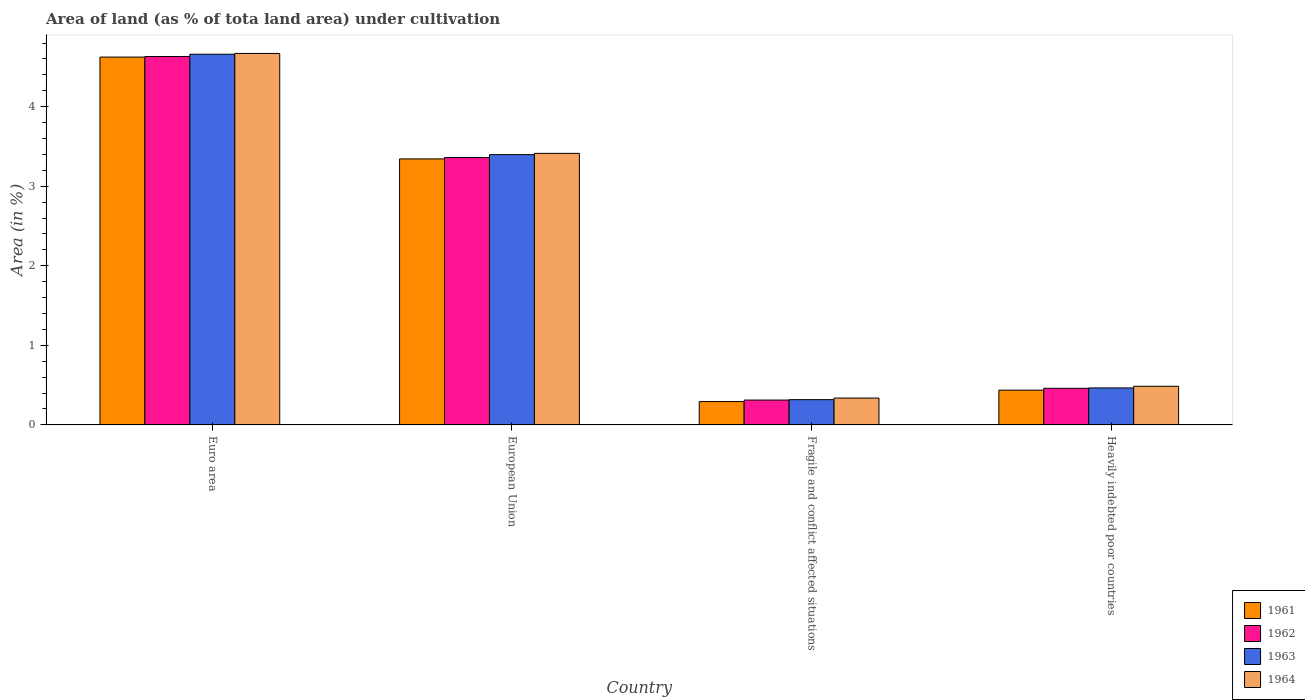How many different coloured bars are there?
Give a very brief answer. 4. How many groups of bars are there?
Provide a succinct answer. 4. Are the number of bars per tick equal to the number of legend labels?
Make the answer very short. Yes. Are the number of bars on each tick of the X-axis equal?
Provide a succinct answer. Yes. What is the label of the 4th group of bars from the left?
Your answer should be compact. Heavily indebted poor countries. In how many cases, is the number of bars for a given country not equal to the number of legend labels?
Your answer should be very brief. 0. What is the percentage of land under cultivation in 1961 in Euro area?
Your answer should be compact. 4.62. Across all countries, what is the maximum percentage of land under cultivation in 1964?
Provide a short and direct response. 4.67. Across all countries, what is the minimum percentage of land under cultivation in 1964?
Ensure brevity in your answer.  0.34. In which country was the percentage of land under cultivation in 1961 maximum?
Make the answer very short. Euro area. In which country was the percentage of land under cultivation in 1961 minimum?
Offer a terse response. Fragile and conflict affected situations. What is the total percentage of land under cultivation in 1961 in the graph?
Offer a terse response. 8.7. What is the difference between the percentage of land under cultivation in 1961 in Fragile and conflict affected situations and that in Heavily indebted poor countries?
Offer a terse response. -0.14. What is the difference between the percentage of land under cultivation in 1962 in Heavily indebted poor countries and the percentage of land under cultivation in 1963 in European Union?
Your answer should be compact. -2.94. What is the average percentage of land under cultivation in 1963 per country?
Your answer should be compact. 2.21. What is the difference between the percentage of land under cultivation of/in 1963 and percentage of land under cultivation of/in 1962 in Fragile and conflict affected situations?
Offer a terse response. 0.01. What is the ratio of the percentage of land under cultivation in 1961 in European Union to that in Fragile and conflict affected situations?
Offer a very short reply. 11.39. Is the percentage of land under cultivation in 1962 in Euro area less than that in Fragile and conflict affected situations?
Offer a terse response. No. Is the difference between the percentage of land under cultivation in 1963 in Euro area and European Union greater than the difference between the percentage of land under cultivation in 1962 in Euro area and European Union?
Give a very brief answer. No. What is the difference between the highest and the second highest percentage of land under cultivation in 1962?
Your answer should be very brief. -2.9. What is the difference between the highest and the lowest percentage of land under cultivation in 1964?
Your response must be concise. 4.33. Is the sum of the percentage of land under cultivation in 1963 in Euro area and Heavily indebted poor countries greater than the maximum percentage of land under cultivation in 1964 across all countries?
Offer a terse response. Yes. What does the 3rd bar from the left in Heavily indebted poor countries represents?
Keep it short and to the point. 1963. What does the 1st bar from the right in European Union represents?
Give a very brief answer. 1964. How many bars are there?
Ensure brevity in your answer.  16. How many countries are there in the graph?
Keep it short and to the point. 4. Are the values on the major ticks of Y-axis written in scientific E-notation?
Make the answer very short. No. Where does the legend appear in the graph?
Your answer should be compact. Bottom right. How many legend labels are there?
Offer a very short reply. 4. What is the title of the graph?
Your response must be concise. Area of land (as % of tota land area) under cultivation. What is the label or title of the Y-axis?
Give a very brief answer. Area (in %). What is the Area (in %) of 1961 in Euro area?
Your answer should be compact. 4.62. What is the Area (in %) in 1962 in Euro area?
Keep it short and to the point. 4.63. What is the Area (in %) in 1963 in Euro area?
Your response must be concise. 4.66. What is the Area (in %) in 1964 in Euro area?
Your answer should be very brief. 4.67. What is the Area (in %) in 1961 in European Union?
Offer a terse response. 3.34. What is the Area (in %) in 1962 in European Union?
Offer a very short reply. 3.36. What is the Area (in %) of 1963 in European Union?
Your answer should be compact. 3.4. What is the Area (in %) of 1964 in European Union?
Offer a very short reply. 3.41. What is the Area (in %) of 1961 in Fragile and conflict affected situations?
Your response must be concise. 0.29. What is the Area (in %) of 1962 in Fragile and conflict affected situations?
Your answer should be very brief. 0.31. What is the Area (in %) of 1963 in Fragile and conflict affected situations?
Your answer should be compact. 0.32. What is the Area (in %) in 1964 in Fragile and conflict affected situations?
Ensure brevity in your answer.  0.34. What is the Area (in %) in 1961 in Heavily indebted poor countries?
Offer a terse response. 0.44. What is the Area (in %) in 1962 in Heavily indebted poor countries?
Offer a terse response. 0.46. What is the Area (in %) in 1963 in Heavily indebted poor countries?
Your answer should be compact. 0.46. What is the Area (in %) in 1964 in Heavily indebted poor countries?
Keep it short and to the point. 0.49. Across all countries, what is the maximum Area (in %) of 1961?
Give a very brief answer. 4.62. Across all countries, what is the maximum Area (in %) of 1962?
Provide a short and direct response. 4.63. Across all countries, what is the maximum Area (in %) in 1963?
Your response must be concise. 4.66. Across all countries, what is the maximum Area (in %) of 1964?
Your answer should be compact. 4.67. Across all countries, what is the minimum Area (in %) of 1961?
Ensure brevity in your answer.  0.29. Across all countries, what is the minimum Area (in %) of 1962?
Your answer should be very brief. 0.31. Across all countries, what is the minimum Area (in %) in 1963?
Offer a very short reply. 0.32. Across all countries, what is the minimum Area (in %) in 1964?
Ensure brevity in your answer.  0.34. What is the total Area (in %) of 1961 in the graph?
Your answer should be compact. 8.7. What is the total Area (in %) of 1962 in the graph?
Offer a terse response. 8.76. What is the total Area (in %) of 1963 in the graph?
Make the answer very short. 8.84. What is the total Area (in %) in 1964 in the graph?
Your answer should be very brief. 8.91. What is the difference between the Area (in %) in 1961 in Euro area and that in European Union?
Your answer should be very brief. 1.28. What is the difference between the Area (in %) in 1962 in Euro area and that in European Union?
Make the answer very short. 1.27. What is the difference between the Area (in %) of 1963 in Euro area and that in European Union?
Provide a short and direct response. 1.26. What is the difference between the Area (in %) in 1964 in Euro area and that in European Union?
Your response must be concise. 1.26. What is the difference between the Area (in %) of 1961 in Euro area and that in Fragile and conflict affected situations?
Provide a succinct answer. 4.33. What is the difference between the Area (in %) of 1962 in Euro area and that in Fragile and conflict affected situations?
Your answer should be very brief. 4.32. What is the difference between the Area (in %) in 1963 in Euro area and that in Fragile and conflict affected situations?
Your answer should be very brief. 4.34. What is the difference between the Area (in %) in 1964 in Euro area and that in Fragile and conflict affected situations?
Offer a very short reply. 4.33. What is the difference between the Area (in %) of 1961 in Euro area and that in Heavily indebted poor countries?
Make the answer very short. 4.19. What is the difference between the Area (in %) of 1962 in Euro area and that in Heavily indebted poor countries?
Offer a terse response. 4.17. What is the difference between the Area (in %) in 1963 in Euro area and that in Heavily indebted poor countries?
Keep it short and to the point. 4.19. What is the difference between the Area (in %) in 1964 in Euro area and that in Heavily indebted poor countries?
Your response must be concise. 4.18. What is the difference between the Area (in %) of 1961 in European Union and that in Fragile and conflict affected situations?
Provide a succinct answer. 3.05. What is the difference between the Area (in %) in 1962 in European Union and that in Fragile and conflict affected situations?
Your answer should be very brief. 3.05. What is the difference between the Area (in %) of 1963 in European Union and that in Fragile and conflict affected situations?
Keep it short and to the point. 3.08. What is the difference between the Area (in %) in 1964 in European Union and that in Fragile and conflict affected situations?
Your answer should be compact. 3.08. What is the difference between the Area (in %) in 1961 in European Union and that in Heavily indebted poor countries?
Your answer should be compact. 2.91. What is the difference between the Area (in %) in 1962 in European Union and that in Heavily indebted poor countries?
Provide a succinct answer. 2.9. What is the difference between the Area (in %) of 1963 in European Union and that in Heavily indebted poor countries?
Make the answer very short. 2.93. What is the difference between the Area (in %) in 1964 in European Union and that in Heavily indebted poor countries?
Keep it short and to the point. 2.93. What is the difference between the Area (in %) in 1961 in Fragile and conflict affected situations and that in Heavily indebted poor countries?
Offer a very short reply. -0.14. What is the difference between the Area (in %) of 1962 in Fragile and conflict affected situations and that in Heavily indebted poor countries?
Ensure brevity in your answer.  -0.15. What is the difference between the Area (in %) in 1963 in Fragile and conflict affected situations and that in Heavily indebted poor countries?
Provide a short and direct response. -0.15. What is the difference between the Area (in %) of 1964 in Fragile and conflict affected situations and that in Heavily indebted poor countries?
Ensure brevity in your answer.  -0.15. What is the difference between the Area (in %) in 1961 in Euro area and the Area (in %) in 1962 in European Union?
Ensure brevity in your answer.  1.26. What is the difference between the Area (in %) of 1961 in Euro area and the Area (in %) of 1963 in European Union?
Give a very brief answer. 1.23. What is the difference between the Area (in %) in 1961 in Euro area and the Area (in %) in 1964 in European Union?
Provide a succinct answer. 1.21. What is the difference between the Area (in %) in 1962 in Euro area and the Area (in %) in 1963 in European Union?
Give a very brief answer. 1.23. What is the difference between the Area (in %) in 1962 in Euro area and the Area (in %) in 1964 in European Union?
Your response must be concise. 1.22. What is the difference between the Area (in %) of 1963 in Euro area and the Area (in %) of 1964 in European Union?
Provide a short and direct response. 1.25. What is the difference between the Area (in %) in 1961 in Euro area and the Area (in %) in 1962 in Fragile and conflict affected situations?
Offer a terse response. 4.31. What is the difference between the Area (in %) of 1961 in Euro area and the Area (in %) of 1963 in Fragile and conflict affected situations?
Offer a terse response. 4.31. What is the difference between the Area (in %) in 1961 in Euro area and the Area (in %) in 1964 in Fragile and conflict affected situations?
Ensure brevity in your answer.  4.29. What is the difference between the Area (in %) in 1962 in Euro area and the Area (in %) in 1963 in Fragile and conflict affected situations?
Keep it short and to the point. 4.31. What is the difference between the Area (in %) of 1962 in Euro area and the Area (in %) of 1964 in Fragile and conflict affected situations?
Your answer should be compact. 4.29. What is the difference between the Area (in %) in 1963 in Euro area and the Area (in %) in 1964 in Fragile and conflict affected situations?
Keep it short and to the point. 4.32. What is the difference between the Area (in %) of 1961 in Euro area and the Area (in %) of 1962 in Heavily indebted poor countries?
Offer a very short reply. 4.16. What is the difference between the Area (in %) in 1961 in Euro area and the Area (in %) in 1963 in Heavily indebted poor countries?
Offer a very short reply. 4.16. What is the difference between the Area (in %) of 1961 in Euro area and the Area (in %) of 1964 in Heavily indebted poor countries?
Provide a short and direct response. 4.14. What is the difference between the Area (in %) of 1962 in Euro area and the Area (in %) of 1963 in Heavily indebted poor countries?
Your answer should be compact. 4.17. What is the difference between the Area (in %) in 1962 in Euro area and the Area (in %) in 1964 in Heavily indebted poor countries?
Your answer should be compact. 4.15. What is the difference between the Area (in %) in 1963 in Euro area and the Area (in %) in 1964 in Heavily indebted poor countries?
Offer a very short reply. 4.17. What is the difference between the Area (in %) of 1961 in European Union and the Area (in %) of 1962 in Fragile and conflict affected situations?
Your response must be concise. 3.03. What is the difference between the Area (in %) in 1961 in European Union and the Area (in %) in 1963 in Fragile and conflict affected situations?
Provide a succinct answer. 3.03. What is the difference between the Area (in %) of 1961 in European Union and the Area (in %) of 1964 in Fragile and conflict affected situations?
Offer a terse response. 3.01. What is the difference between the Area (in %) in 1962 in European Union and the Area (in %) in 1963 in Fragile and conflict affected situations?
Make the answer very short. 3.04. What is the difference between the Area (in %) of 1962 in European Union and the Area (in %) of 1964 in Fragile and conflict affected situations?
Provide a short and direct response. 3.02. What is the difference between the Area (in %) in 1963 in European Union and the Area (in %) in 1964 in Fragile and conflict affected situations?
Provide a short and direct response. 3.06. What is the difference between the Area (in %) in 1961 in European Union and the Area (in %) in 1962 in Heavily indebted poor countries?
Your answer should be very brief. 2.88. What is the difference between the Area (in %) of 1961 in European Union and the Area (in %) of 1963 in Heavily indebted poor countries?
Give a very brief answer. 2.88. What is the difference between the Area (in %) in 1961 in European Union and the Area (in %) in 1964 in Heavily indebted poor countries?
Offer a terse response. 2.86. What is the difference between the Area (in %) of 1962 in European Union and the Area (in %) of 1963 in Heavily indebted poor countries?
Your answer should be very brief. 2.9. What is the difference between the Area (in %) in 1962 in European Union and the Area (in %) in 1964 in Heavily indebted poor countries?
Your response must be concise. 2.88. What is the difference between the Area (in %) of 1963 in European Union and the Area (in %) of 1964 in Heavily indebted poor countries?
Your response must be concise. 2.91. What is the difference between the Area (in %) of 1961 in Fragile and conflict affected situations and the Area (in %) of 1962 in Heavily indebted poor countries?
Provide a short and direct response. -0.17. What is the difference between the Area (in %) of 1961 in Fragile and conflict affected situations and the Area (in %) of 1963 in Heavily indebted poor countries?
Make the answer very short. -0.17. What is the difference between the Area (in %) of 1961 in Fragile and conflict affected situations and the Area (in %) of 1964 in Heavily indebted poor countries?
Keep it short and to the point. -0.19. What is the difference between the Area (in %) in 1962 in Fragile and conflict affected situations and the Area (in %) in 1963 in Heavily indebted poor countries?
Your answer should be compact. -0.15. What is the difference between the Area (in %) of 1962 in Fragile and conflict affected situations and the Area (in %) of 1964 in Heavily indebted poor countries?
Ensure brevity in your answer.  -0.17. What is the difference between the Area (in %) of 1963 in Fragile and conflict affected situations and the Area (in %) of 1964 in Heavily indebted poor countries?
Offer a very short reply. -0.17. What is the average Area (in %) of 1961 per country?
Offer a very short reply. 2.17. What is the average Area (in %) of 1962 per country?
Your answer should be compact. 2.19. What is the average Area (in %) of 1963 per country?
Your answer should be very brief. 2.21. What is the average Area (in %) in 1964 per country?
Make the answer very short. 2.23. What is the difference between the Area (in %) of 1961 and Area (in %) of 1962 in Euro area?
Your answer should be very brief. -0.01. What is the difference between the Area (in %) of 1961 and Area (in %) of 1963 in Euro area?
Keep it short and to the point. -0.04. What is the difference between the Area (in %) in 1961 and Area (in %) in 1964 in Euro area?
Give a very brief answer. -0.05. What is the difference between the Area (in %) of 1962 and Area (in %) of 1963 in Euro area?
Your answer should be compact. -0.03. What is the difference between the Area (in %) in 1962 and Area (in %) in 1964 in Euro area?
Your response must be concise. -0.04. What is the difference between the Area (in %) in 1963 and Area (in %) in 1964 in Euro area?
Make the answer very short. -0.01. What is the difference between the Area (in %) in 1961 and Area (in %) in 1962 in European Union?
Offer a terse response. -0.02. What is the difference between the Area (in %) of 1961 and Area (in %) of 1963 in European Union?
Your answer should be compact. -0.05. What is the difference between the Area (in %) of 1961 and Area (in %) of 1964 in European Union?
Offer a terse response. -0.07. What is the difference between the Area (in %) of 1962 and Area (in %) of 1963 in European Union?
Your answer should be compact. -0.04. What is the difference between the Area (in %) of 1962 and Area (in %) of 1964 in European Union?
Provide a succinct answer. -0.05. What is the difference between the Area (in %) of 1963 and Area (in %) of 1964 in European Union?
Offer a terse response. -0.02. What is the difference between the Area (in %) in 1961 and Area (in %) in 1962 in Fragile and conflict affected situations?
Offer a very short reply. -0.02. What is the difference between the Area (in %) of 1961 and Area (in %) of 1963 in Fragile and conflict affected situations?
Provide a short and direct response. -0.02. What is the difference between the Area (in %) in 1961 and Area (in %) in 1964 in Fragile and conflict affected situations?
Give a very brief answer. -0.04. What is the difference between the Area (in %) in 1962 and Area (in %) in 1963 in Fragile and conflict affected situations?
Offer a terse response. -0.01. What is the difference between the Area (in %) of 1962 and Area (in %) of 1964 in Fragile and conflict affected situations?
Offer a very short reply. -0.03. What is the difference between the Area (in %) in 1963 and Area (in %) in 1964 in Fragile and conflict affected situations?
Give a very brief answer. -0.02. What is the difference between the Area (in %) of 1961 and Area (in %) of 1962 in Heavily indebted poor countries?
Keep it short and to the point. -0.02. What is the difference between the Area (in %) of 1961 and Area (in %) of 1963 in Heavily indebted poor countries?
Your answer should be compact. -0.03. What is the difference between the Area (in %) in 1961 and Area (in %) in 1964 in Heavily indebted poor countries?
Your answer should be very brief. -0.05. What is the difference between the Area (in %) of 1962 and Area (in %) of 1963 in Heavily indebted poor countries?
Your response must be concise. -0. What is the difference between the Area (in %) in 1962 and Area (in %) in 1964 in Heavily indebted poor countries?
Your answer should be compact. -0.03. What is the difference between the Area (in %) in 1963 and Area (in %) in 1964 in Heavily indebted poor countries?
Keep it short and to the point. -0.02. What is the ratio of the Area (in %) in 1961 in Euro area to that in European Union?
Provide a short and direct response. 1.38. What is the ratio of the Area (in %) in 1962 in Euro area to that in European Union?
Your answer should be very brief. 1.38. What is the ratio of the Area (in %) in 1963 in Euro area to that in European Union?
Your response must be concise. 1.37. What is the ratio of the Area (in %) in 1964 in Euro area to that in European Union?
Offer a terse response. 1.37. What is the ratio of the Area (in %) of 1961 in Euro area to that in Fragile and conflict affected situations?
Your answer should be very brief. 15.76. What is the ratio of the Area (in %) in 1962 in Euro area to that in Fragile and conflict affected situations?
Keep it short and to the point. 14.83. What is the ratio of the Area (in %) in 1963 in Euro area to that in Fragile and conflict affected situations?
Offer a terse response. 14.67. What is the ratio of the Area (in %) of 1964 in Euro area to that in Fragile and conflict affected situations?
Offer a terse response. 13.83. What is the ratio of the Area (in %) in 1961 in Euro area to that in Heavily indebted poor countries?
Keep it short and to the point. 10.58. What is the ratio of the Area (in %) of 1962 in Euro area to that in Heavily indebted poor countries?
Offer a very short reply. 10.06. What is the ratio of the Area (in %) in 1963 in Euro area to that in Heavily indebted poor countries?
Provide a succinct answer. 10.02. What is the ratio of the Area (in %) of 1964 in Euro area to that in Heavily indebted poor countries?
Offer a terse response. 9.61. What is the ratio of the Area (in %) of 1961 in European Union to that in Fragile and conflict affected situations?
Your response must be concise. 11.39. What is the ratio of the Area (in %) in 1962 in European Union to that in Fragile and conflict affected situations?
Provide a short and direct response. 10.76. What is the ratio of the Area (in %) in 1963 in European Union to that in Fragile and conflict affected situations?
Give a very brief answer. 10.7. What is the ratio of the Area (in %) of 1964 in European Union to that in Fragile and conflict affected situations?
Your answer should be compact. 10.11. What is the ratio of the Area (in %) in 1961 in European Union to that in Heavily indebted poor countries?
Give a very brief answer. 7.65. What is the ratio of the Area (in %) in 1962 in European Union to that in Heavily indebted poor countries?
Give a very brief answer. 7.3. What is the ratio of the Area (in %) of 1963 in European Union to that in Heavily indebted poor countries?
Keep it short and to the point. 7.31. What is the ratio of the Area (in %) of 1964 in European Union to that in Heavily indebted poor countries?
Give a very brief answer. 7.03. What is the ratio of the Area (in %) of 1961 in Fragile and conflict affected situations to that in Heavily indebted poor countries?
Give a very brief answer. 0.67. What is the ratio of the Area (in %) in 1962 in Fragile and conflict affected situations to that in Heavily indebted poor countries?
Your answer should be very brief. 0.68. What is the ratio of the Area (in %) in 1963 in Fragile and conflict affected situations to that in Heavily indebted poor countries?
Keep it short and to the point. 0.68. What is the ratio of the Area (in %) in 1964 in Fragile and conflict affected situations to that in Heavily indebted poor countries?
Offer a terse response. 0.69. What is the difference between the highest and the second highest Area (in %) in 1961?
Keep it short and to the point. 1.28. What is the difference between the highest and the second highest Area (in %) in 1962?
Ensure brevity in your answer.  1.27. What is the difference between the highest and the second highest Area (in %) in 1963?
Offer a terse response. 1.26. What is the difference between the highest and the second highest Area (in %) in 1964?
Give a very brief answer. 1.26. What is the difference between the highest and the lowest Area (in %) of 1961?
Ensure brevity in your answer.  4.33. What is the difference between the highest and the lowest Area (in %) of 1962?
Give a very brief answer. 4.32. What is the difference between the highest and the lowest Area (in %) in 1963?
Provide a succinct answer. 4.34. What is the difference between the highest and the lowest Area (in %) in 1964?
Offer a terse response. 4.33. 